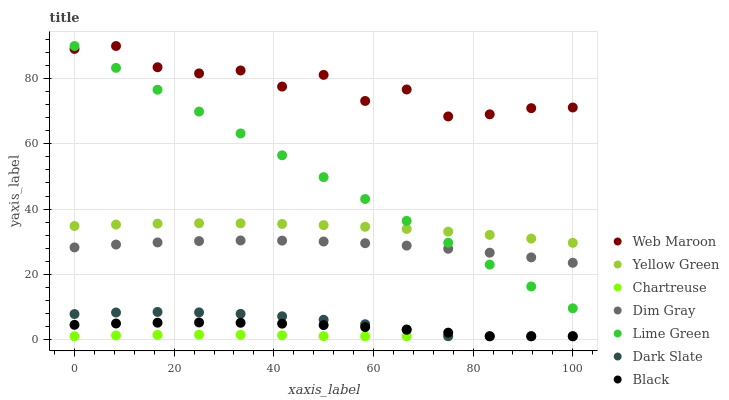Does Chartreuse have the minimum area under the curve?
Answer yes or no. Yes. Does Web Maroon have the maximum area under the curve?
Answer yes or no. Yes. Does Yellow Green have the minimum area under the curve?
Answer yes or no. No. Does Yellow Green have the maximum area under the curve?
Answer yes or no. No. Is Lime Green the smoothest?
Answer yes or no. Yes. Is Web Maroon the roughest?
Answer yes or no. Yes. Is Yellow Green the smoothest?
Answer yes or no. No. Is Yellow Green the roughest?
Answer yes or no. No. Does Dark Slate have the lowest value?
Answer yes or no. Yes. Does Yellow Green have the lowest value?
Answer yes or no. No. Does Lime Green have the highest value?
Answer yes or no. Yes. Does Yellow Green have the highest value?
Answer yes or no. No. Is Dark Slate less than Yellow Green?
Answer yes or no. Yes. Is Dim Gray greater than Black?
Answer yes or no. Yes. Does Yellow Green intersect Lime Green?
Answer yes or no. Yes. Is Yellow Green less than Lime Green?
Answer yes or no. No. Is Yellow Green greater than Lime Green?
Answer yes or no. No. Does Dark Slate intersect Yellow Green?
Answer yes or no. No. 